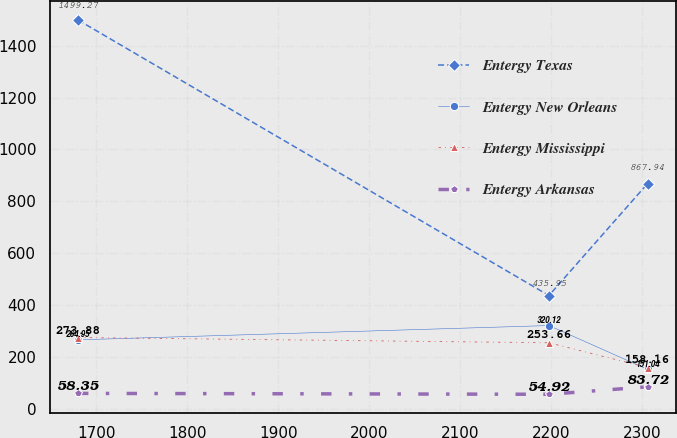<chart> <loc_0><loc_0><loc_500><loc_500><line_chart><ecel><fcel>Entergy Texas<fcel>Entergy New Orleans<fcel>Entergy Mississippi<fcel>Entergy Arkansas<nl><fcel>1680.05<fcel>1499.27<fcel>264.95<fcel>273.88<fcel>58.35<nl><fcel>2197.42<fcel>435.95<fcel>320.12<fcel>253.66<fcel>54.92<nl><fcel>2305.83<fcel>867.94<fcel>151.04<fcel>158.16<fcel>83.72<nl></chart> 